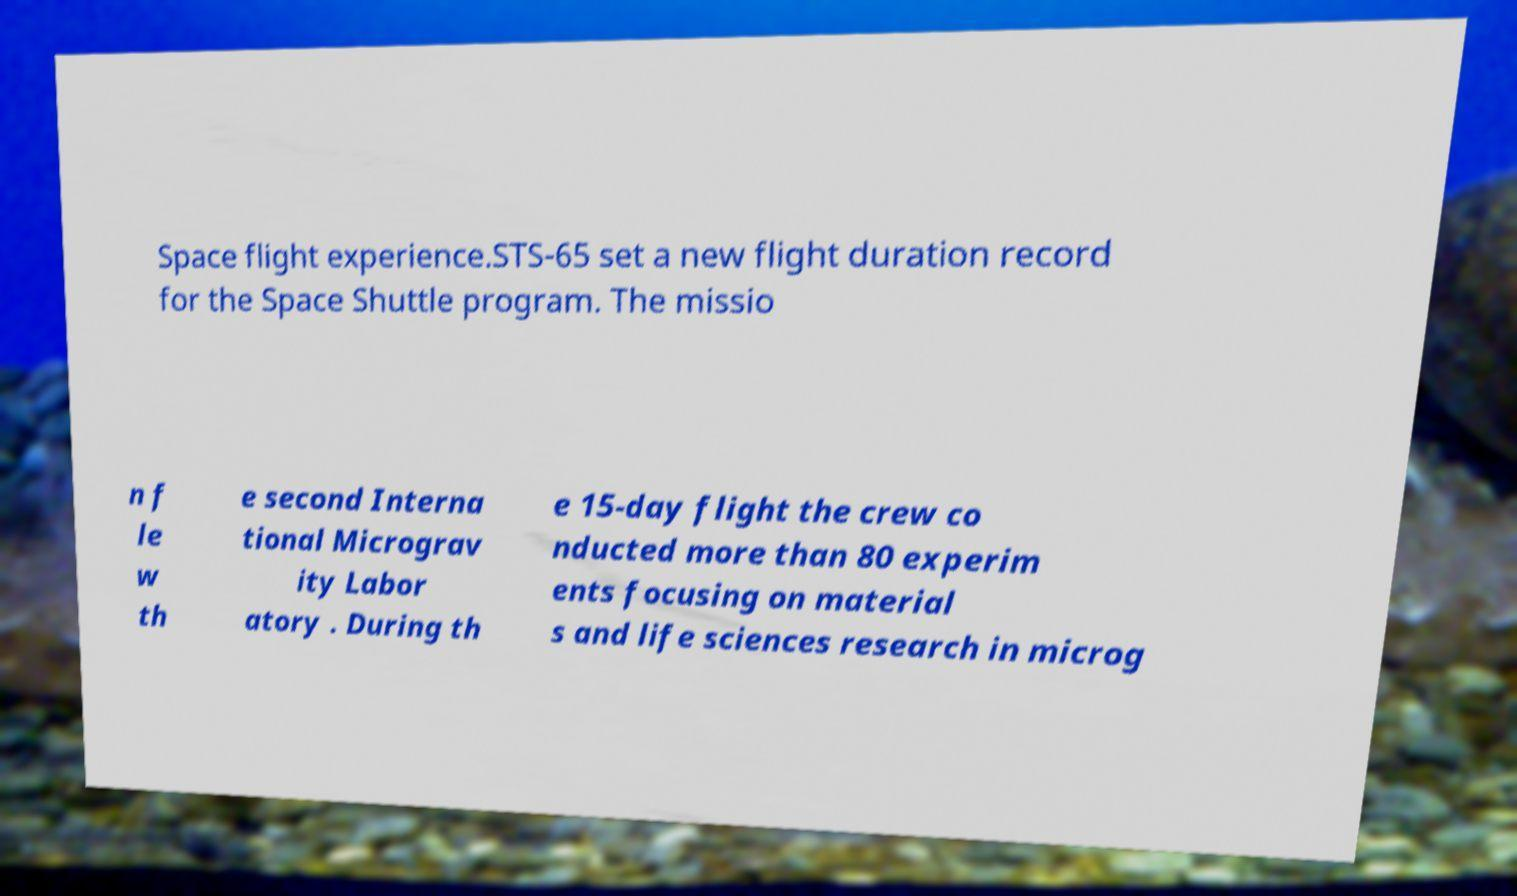I need the written content from this picture converted into text. Can you do that? Space flight experience.STS-65 set a new flight duration record for the Space Shuttle program. The missio n f le w th e second Interna tional Micrograv ity Labor atory . During th e 15-day flight the crew co nducted more than 80 experim ents focusing on material s and life sciences research in microg 